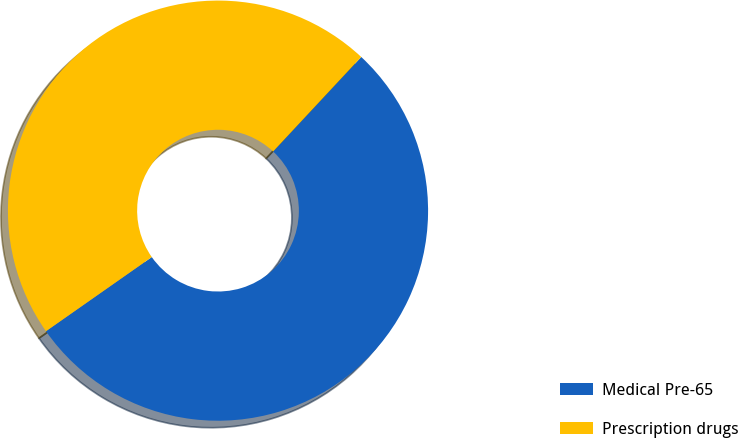Convert chart to OTSL. <chart><loc_0><loc_0><loc_500><loc_500><pie_chart><fcel>Medical Pre-65<fcel>Prescription drugs<nl><fcel>53.33%<fcel>46.67%<nl></chart> 